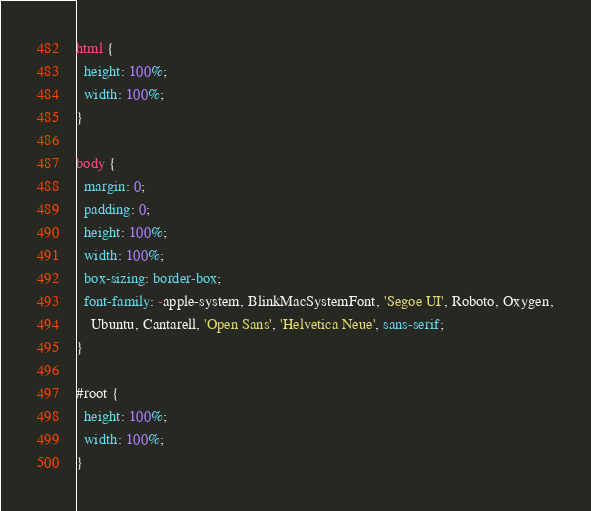<code> <loc_0><loc_0><loc_500><loc_500><_CSS_>html {
  height: 100%;
  width: 100%;
}

body {
  margin: 0;
  padding: 0;
  height: 100%;
  width: 100%;
  box-sizing: border-box;
  font-family: -apple-system, BlinkMacSystemFont, 'Segoe UI', Roboto, Oxygen,
    Ubuntu, Cantarell, 'Open Sans', 'Helvetica Neue', sans-serif;
}

#root {
  height: 100%;
  width: 100%;
}
</code> 